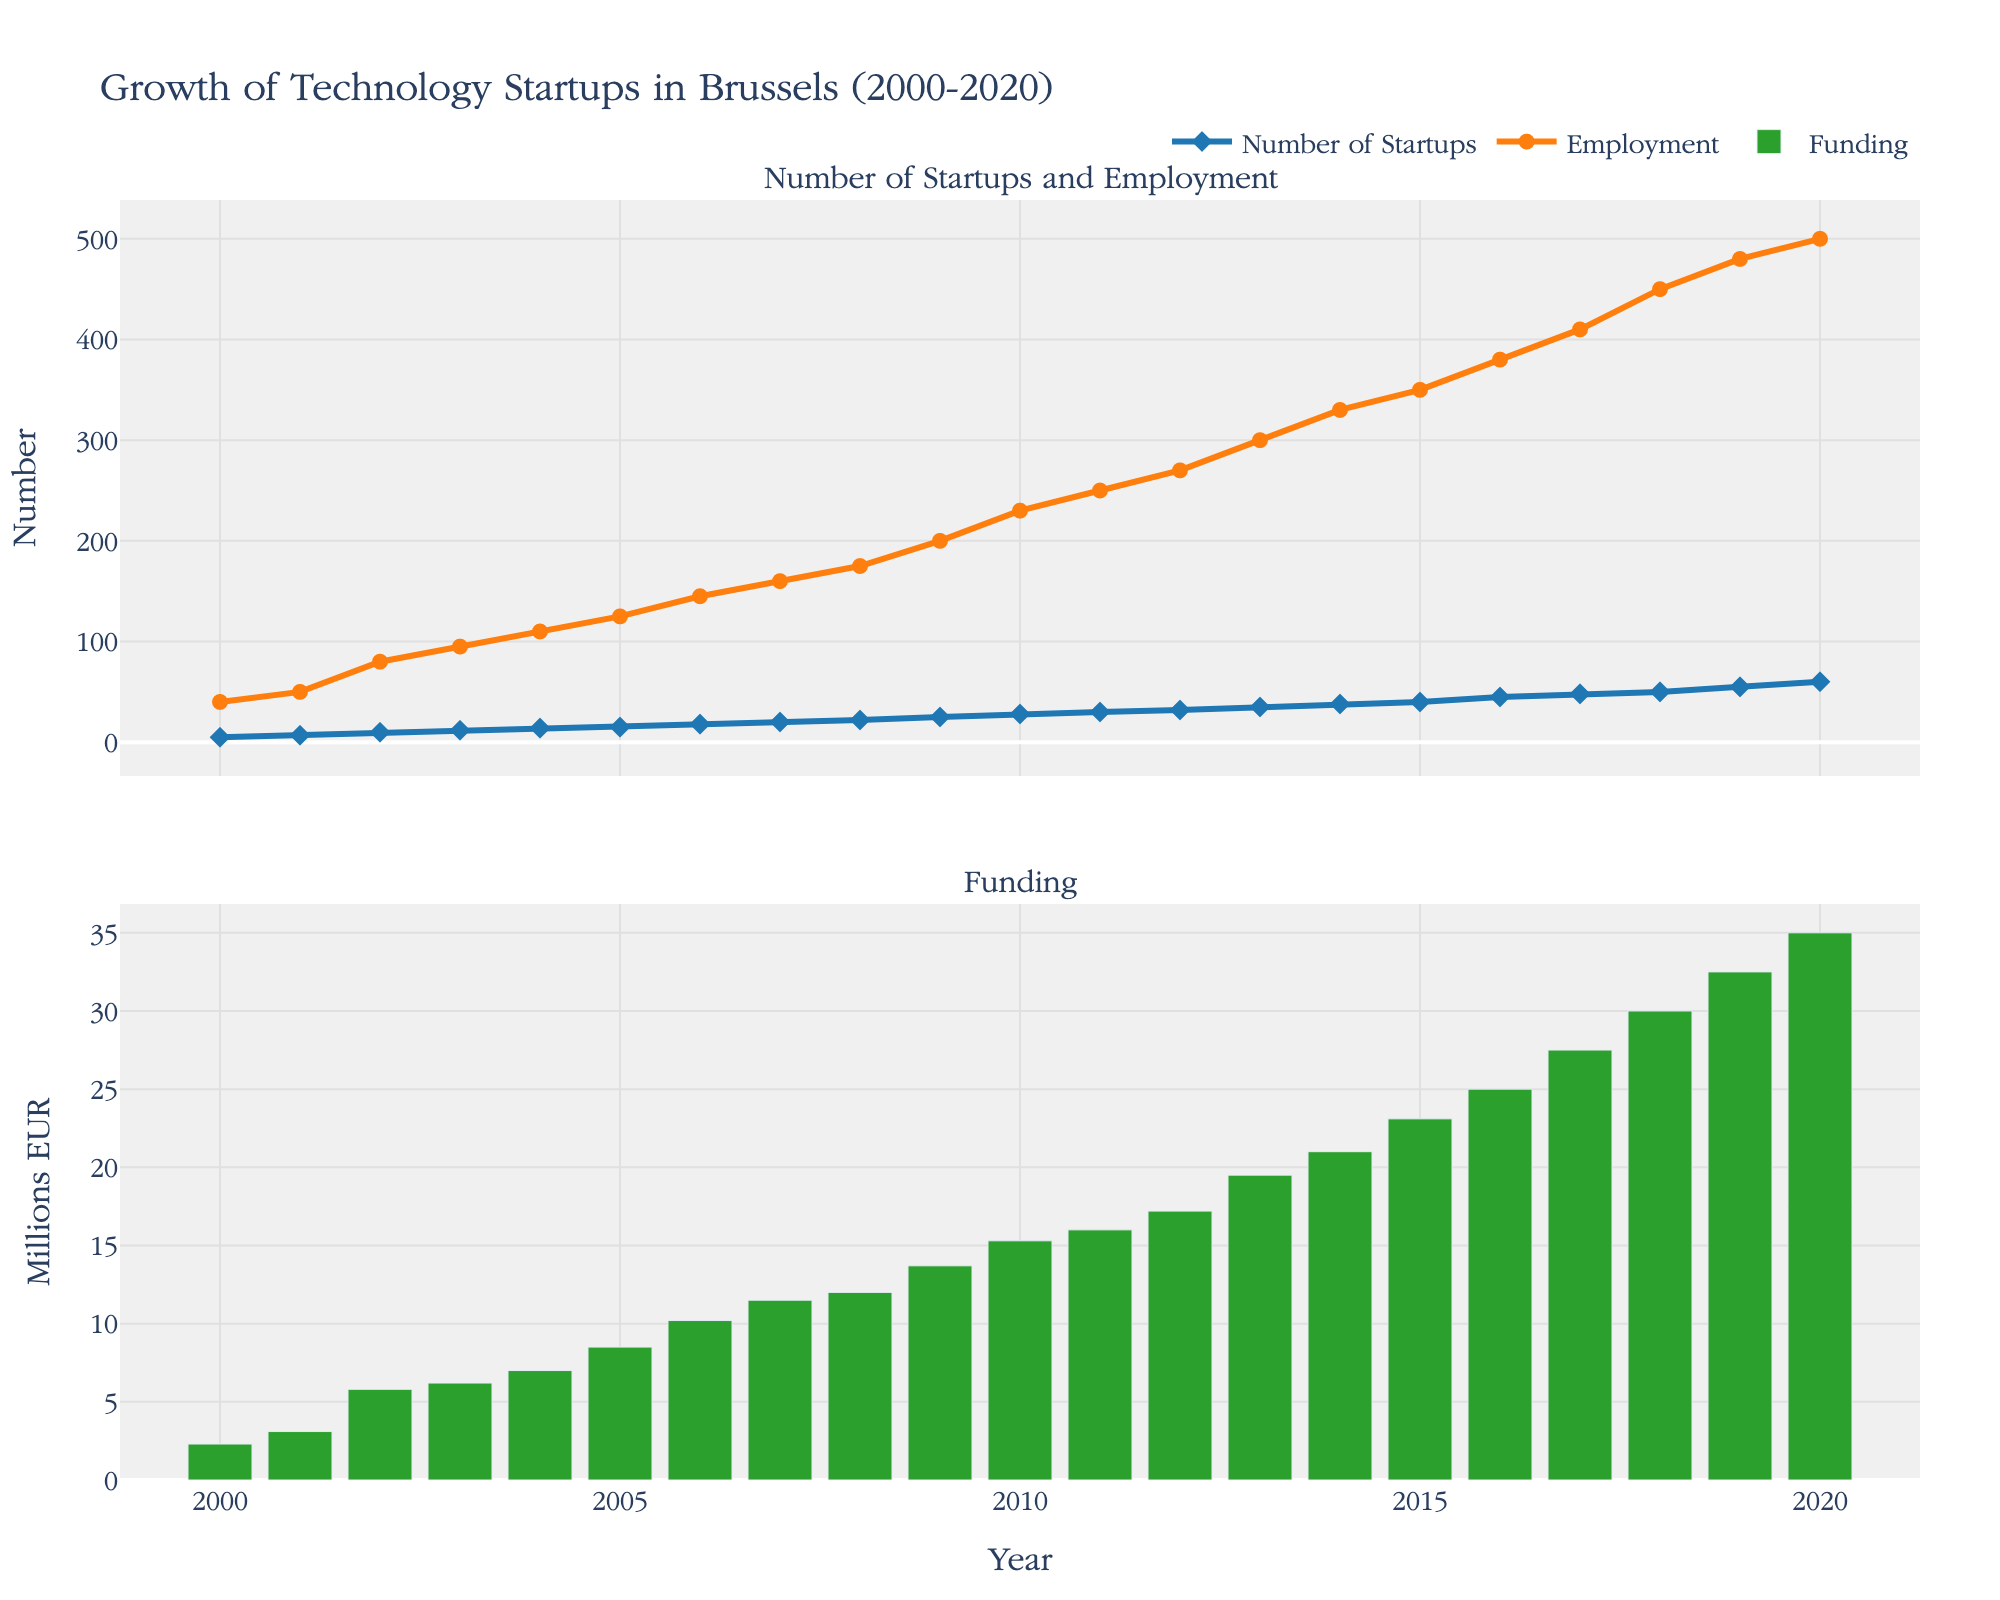What are the titles of the two subplots? The figure displays two subplots under the main title "Growth of Technology Startups in Brussels (2000-2020)". The titles for the subplots are "Number of Startups and Employment" at the top and "Funding" at the bottom.
Answer: "Number of Startups and Employment" and "Funding" Between which years did the number of startups grow the most rapidly? Observing the "Number of Startups" line in the top subplot, the steepest increase appears between 2015 and 2016, where the number of startups rose from 40 to 45.
Answer: 2015 to 2016 Compare the trends of employment and funding from 2000 to 2020. Which increased more steadily? Both employment and funding trends are upward. However, employment (orange line in the top subplot) shows more consistent year-over-year increases compared to the more stepped increase in funding shown as bars in the bottom subplot.
Answer: Employment What was the employment in the year 2010? Checking the orange line representing employment in the top subplot, the value in 2010 is indicated around 230.
Answer: 230 How much funding was reported in 2007? Referring to the bars in the bottom subplot, the funding amount in 2007 is close to 11.5 million EUR.
Answer: 11.5 million EUR From which year did the number of technology startups exceed 50? Observing the blue line for the "Number of Startups" in the top subplot, the value exceeds 50 in 2019.
Answer: 2019 What was the difference in employment between 2010 and 2015? Employment in 2010 is marked at 230 and in 2015 at 350. The difference is 350 - 230.
Answer: 120 In which year was the growth in funding the highest compared to the previous year? The biggest jump in funding, represented by green bars, occurred between 2017 (27.5 million EUR) and 2018 (30 million EUR), an increase of 2.5 million EUR.
Answer: 2017 to 2018 How many startups were there in 2003, and how many were there by 2020? The data points show that there were 12 startups in 2003 and 60 in 2020, as indicated by the blue line in the top subplot.
Answer: 12 in 2003, 60 in 2020 